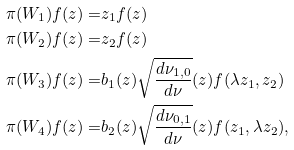Convert formula to latex. <formula><loc_0><loc_0><loc_500><loc_500>\pi ( W _ { 1 } ) f ( z ) = & z _ { 1 } f ( z ) \\ \pi ( W _ { 2 } ) f ( z ) = & z _ { 2 } f ( z ) \\ \pi ( W _ { 3 } ) f ( z ) = & b _ { 1 } ( z ) \sqrt { \frac { d \nu _ { 1 , 0 } } { d \nu } } ( z ) f ( \lambda z _ { 1 } , z _ { 2 } ) \\ \pi ( W _ { 4 } ) f ( z ) = & b _ { 2 } ( z ) \sqrt { \frac { d \nu _ { 0 , 1 } } { d \nu } } ( z ) f ( z _ { 1 } , \lambda z _ { 2 } ) ,</formula> 